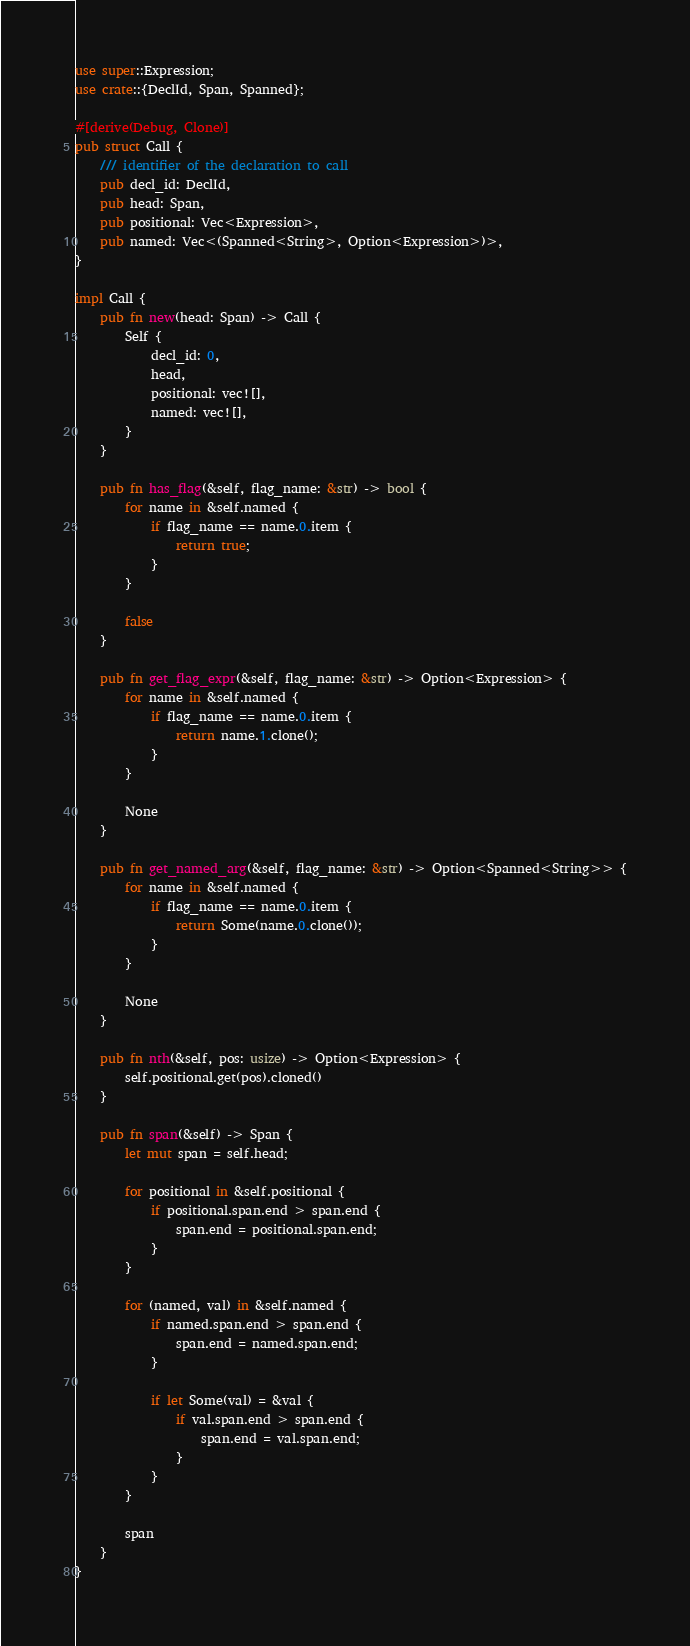Convert code to text. <code><loc_0><loc_0><loc_500><loc_500><_Rust_>use super::Expression;
use crate::{DeclId, Span, Spanned};

#[derive(Debug, Clone)]
pub struct Call {
    /// identifier of the declaration to call
    pub decl_id: DeclId,
    pub head: Span,
    pub positional: Vec<Expression>,
    pub named: Vec<(Spanned<String>, Option<Expression>)>,
}

impl Call {
    pub fn new(head: Span) -> Call {
        Self {
            decl_id: 0,
            head,
            positional: vec![],
            named: vec![],
        }
    }

    pub fn has_flag(&self, flag_name: &str) -> bool {
        for name in &self.named {
            if flag_name == name.0.item {
                return true;
            }
        }

        false
    }

    pub fn get_flag_expr(&self, flag_name: &str) -> Option<Expression> {
        for name in &self.named {
            if flag_name == name.0.item {
                return name.1.clone();
            }
        }

        None
    }

    pub fn get_named_arg(&self, flag_name: &str) -> Option<Spanned<String>> {
        for name in &self.named {
            if flag_name == name.0.item {
                return Some(name.0.clone());
            }
        }

        None
    }

    pub fn nth(&self, pos: usize) -> Option<Expression> {
        self.positional.get(pos).cloned()
    }

    pub fn span(&self) -> Span {
        let mut span = self.head;

        for positional in &self.positional {
            if positional.span.end > span.end {
                span.end = positional.span.end;
            }
        }

        for (named, val) in &self.named {
            if named.span.end > span.end {
                span.end = named.span.end;
            }

            if let Some(val) = &val {
                if val.span.end > span.end {
                    span.end = val.span.end;
                }
            }
        }

        span
    }
}
</code> 